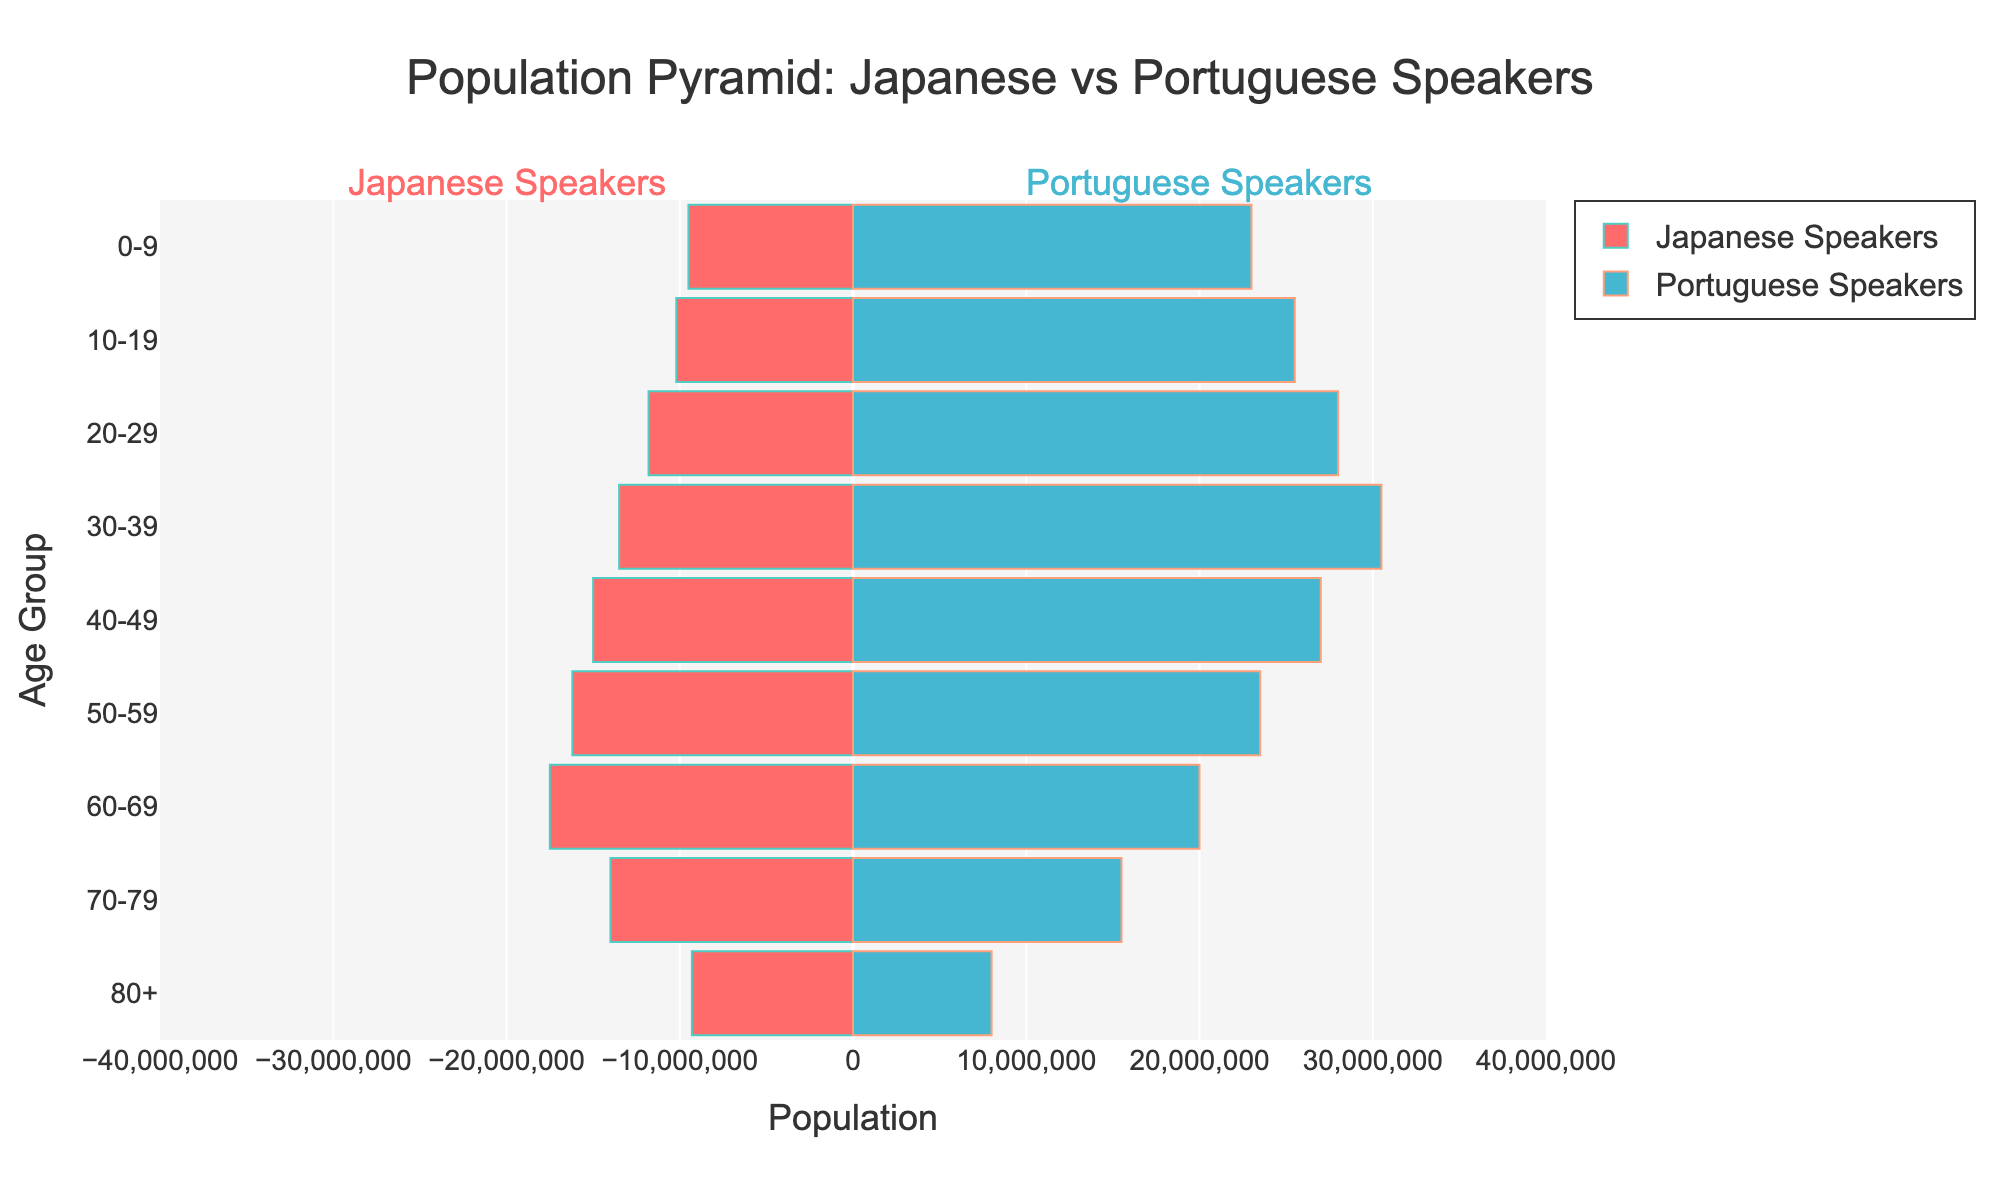What is the title of the figure? The title is usually displayed at the top of the figure in larger and bold text, providing a quick summary of what the plot is showing.
Answer: "Population Pyramid: Japanese vs Portuguese Speakers" Which age group has the highest number of Japanese speakers? By looking at the bars associated with Japanese speakers and comparing their lengths, we determine that the longest bar represents the age group with the highest population.
Answer: 60-69 How many more Portuguese speakers are there in the 30-39 age group compared to Japanese speakers? First, identify the number of Portuguese and Japanese speakers in the 30-39 age group from the lengths of their respective bars. Then, subtract the number of Japanese speakers from the number of Portuguese speakers.
Answer: 17,000,000 In which age group is the difference between Japanese and Portuguese speakers the smallest? Examine the difference between the lengths of the bars for each age group and identify the age group where this difference is the smallest.
Answer: 80+ What is the total number of Japanese speakers aged 50 and above? Add the numbers for all age groups starting from 50-59 and above (50-59, 60-69, 70-79, 80+).
Answer: 57,600,000 Which age group has more Portuguese speakers than Japanese speakers? Compare the lengths of the bars for each age group, focusing on which groups have Portuguese speaker bars longer than those of Japanese speakers.
Answer: 0-9, 10-19, 20-29, 30-39 Do the Portuguese speakers have a higher population in the age group 60-69 compared to Japanese speakers? Check the lengths of the respective bars for the 60-69 age group to determine if the bar for Portuguese speakers is longer than that for Japanese speakers.
Answer: No For the age group 40-49, what is the combined total of Japanese and Portuguese speakers? Add the numbers of Japanese speakers and Portuguese speakers for the 40-49 age group.
Answer: 42,000,000 What is the difference in the population of Japanese speakers between the age groups 30-39 and 40-49 combined? Subtract the number of Japanese speakers in the 30-39 age group from the number in the 40-49 age group.
Answer: 1,500,000 